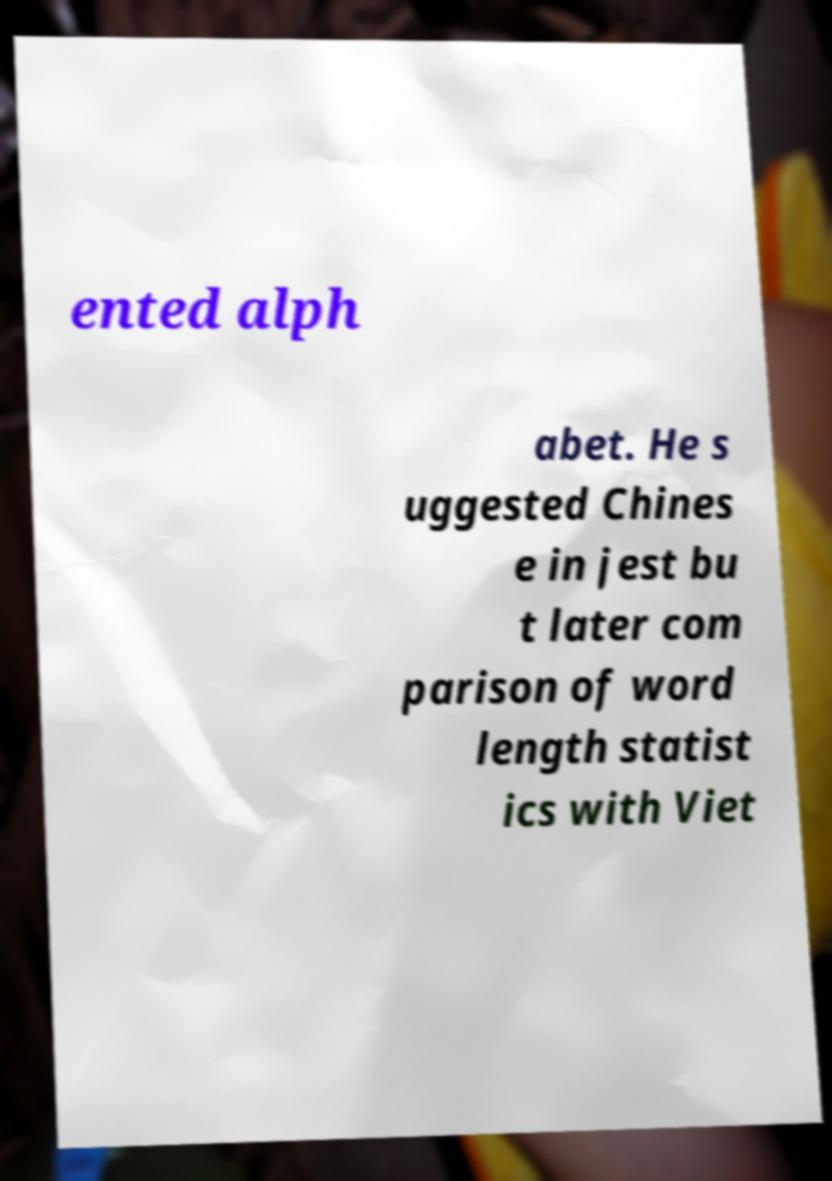Please identify and transcribe the text found in this image. ented alph abet. He s uggested Chines e in jest bu t later com parison of word length statist ics with Viet 